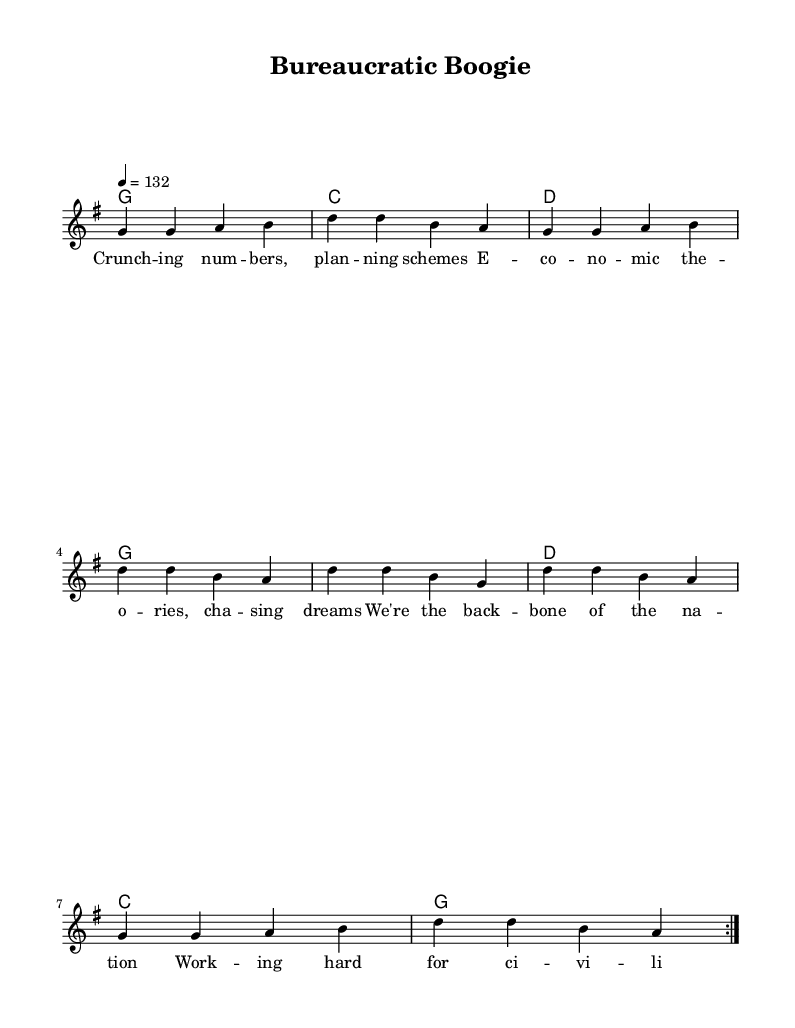What is the key signature of this music? The key signature indicated in the sheet music is G major, which has one sharp (F#).
Answer: G major What is the time signature of this piece? The time signature displayed at the beginning of the sheet music is 4/4, meaning there are four beats in each measure.
Answer: 4/4 What is the tempo marking for the piece? The tempo marking shows a quarter note equals 132 beats per minute, setting a brisk pace for the music.
Answer: 132 How many times is the main melody repeated in the score? The melody is indicated with a "volta 2" sign, meaning it should be played twice.
Answer: 2 What is the first lyric in the verse? The first lyric is the word "Crunch," which is the opener of the first line of the verse lyrics.
Answer: Crunch Which chord follows the first measure in the harmonies? The first measure in the harmonies corresponds to a G chord in the chord progression.
Answer: G What is the overall theme of the lyrics in this song? The lyrics celebrate the hard work and contributions of government employees in economic planning, indicating a focus on national progress and service.
Answer: Hard work 